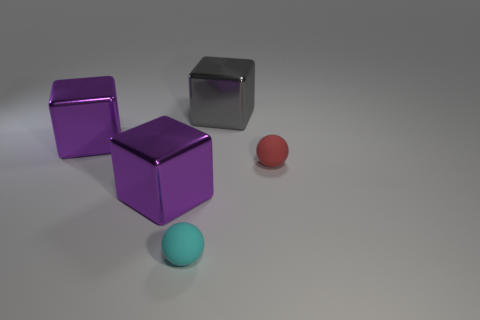How big is the cyan object?
Your answer should be compact. Small. Are there fewer large brown metal blocks than gray metal cubes?
Give a very brief answer. Yes. The large purple metal thing that is in front of the small red ball has what shape?
Give a very brief answer. Cube. Is there a small red matte object that is behind the gray metallic cube to the left of the tiny red matte sphere?
Your response must be concise. No. What number of small balls are made of the same material as the cyan thing?
Ensure brevity in your answer.  1. What is the size of the metallic block that is on the left side of the purple shiny object in front of the thing to the right of the large gray shiny thing?
Provide a short and direct response. Large. There is a cyan rubber sphere; how many big objects are to the left of it?
Your response must be concise. 2. Are there more objects than large cyan rubber spheres?
Offer a very short reply. Yes. How big is the object that is both right of the tiny cyan rubber sphere and on the left side of the tiny red rubber sphere?
Give a very brief answer. Large. The ball behind the tiny sphere that is in front of the rubber thing that is to the right of the gray metallic block is made of what material?
Offer a very short reply. Rubber. 